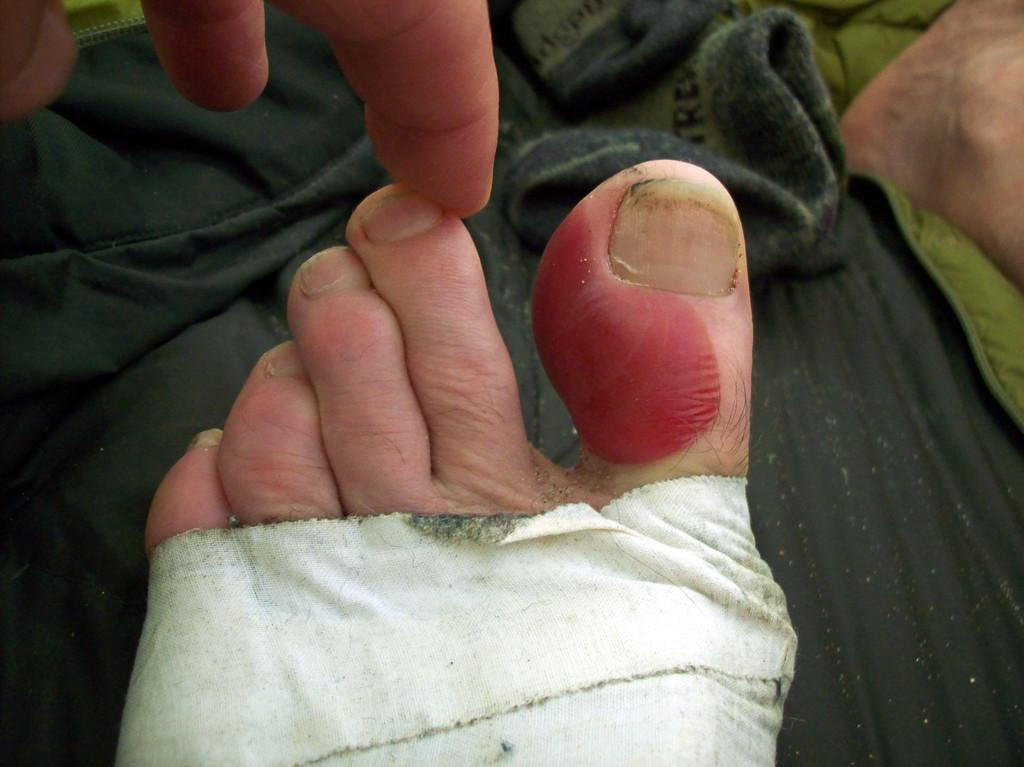What is the main subject in the foreground of the image? There is a person in the foreground of the image. Can you describe any specific details about the person? The person has a bandage on their leg. What is visible at the bottom of the image? There is a cloth at the bottom of the image. What type of system is being used to improve the acoustics in the image? There is no information about a system or acoustics in the image; it primarily features a person with a bandage on their leg and a cloth at the bottom. 